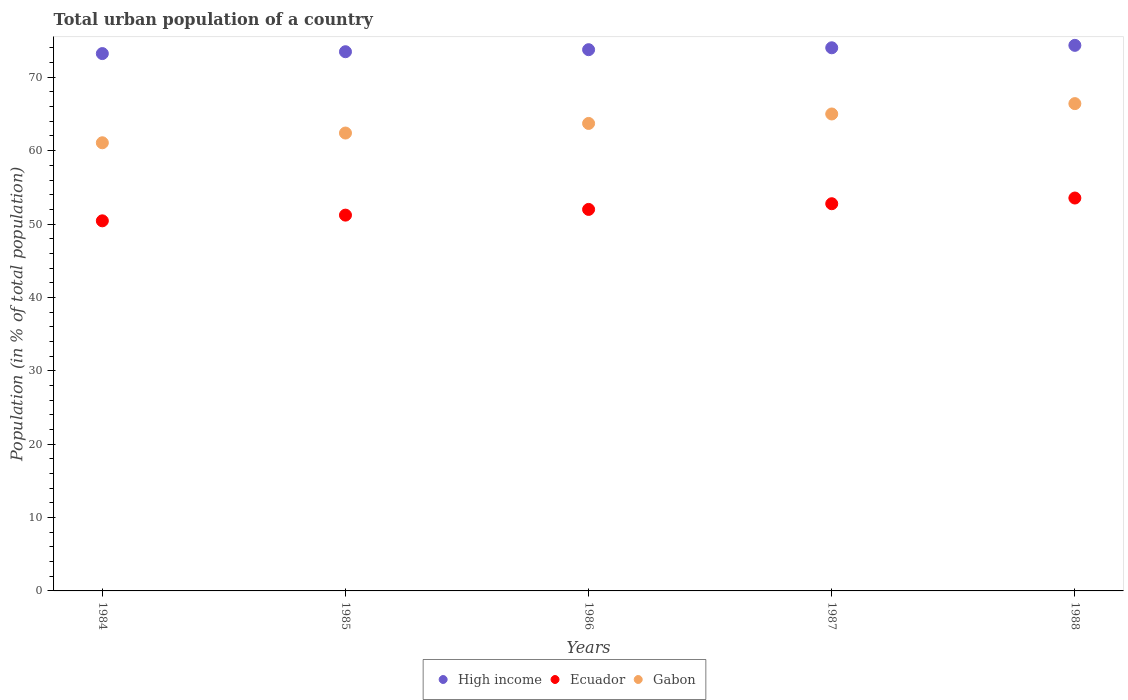What is the urban population in Gabon in 1986?
Your answer should be compact. 63.71. Across all years, what is the maximum urban population in Gabon?
Offer a terse response. 66.41. Across all years, what is the minimum urban population in Gabon?
Your response must be concise. 61.08. In which year was the urban population in Gabon minimum?
Provide a short and direct response. 1984. What is the total urban population in High income in the graph?
Provide a short and direct response. 368.85. What is the difference between the urban population in Gabon in 1984 and that in 1985?
Ensure brevity in your answer.  -1.33. What is the difference between the urban population in Ecuador in 1988 and the urban population in High income in 1986?
Ensure brevity in your answer.  -20.22. What is the average urban population in Gabon per year?
Offer a terse response. 63.72. In the year 1985, what is the difference between the urban population in High income and urban population in Ecuador?
Make the answer very short. 22.27. In how many years, is the urban population in Gabon greater than 42 %?
Your answer should be very brief. 5. What is the ratio of the urban population in Gabon in 1985 to that in 1988?
Ensure brevity in your answer.  0.94. Is the difference between the urban population in High income in 1986 and 1987 greater than the difference between the urban population in Ecuador in 1986 and 1987?
Give a very brief answer. Yes. What is the difference between the highest and the second highest urban population in Ecuador?
Your response must be concise. 0.78. What is the difference between the highest and the lowest urban population in Ecuador?
Keep it short and to the point. 3.11. Is the sum of the urban population in Gabon in 1985 and 1986 greater than the maximum urban population in Ecuador across all years?
Your response must be concise. Yes. Does the urban population in High income monotonically increase over the years?
Provide a succinct answer. Yes. Is the urban population in Gabon strictly greater than the urban population in High income over the years?
Offer a terse response. No. Is the urban population in Ecuador strictly less than the urban population in High income over the years?
Keep it short and to the point. Yes. How many dotlines are there?
Provide a short and direct response. 3. How many years are there in the graph?
Offer a terse response. 5. What is the difference between two consecutive major ticks on the Y-axis?
Your answer should be very brief. 10. Are the values on the major ticks of Y-axis written in scientific E-notation?
Offer a terse response. No. Does the graph contain any zero values?
Your answer should be compact. No. Where does the legend appear in the graph?
Provide a succinct answer. Bottom center. How are the legend labels stacked?
Make the answer very short. Horizontal. What is the title of the graph?
Your answer should be compact. Total urban population of a country. Does "Low & middle income" appear as one of the legend labels in the graph?
Keep it short and to the point. No. What is the label or title of the X-axis?
Give a very brief answer. Years. What is the label or title of the Y-axis?
Provide a short and direct response. Population (in % of total population). What is the Population (in % of total population) of High income in 1984?
Ensure brevity in your answer.  73.23. What is the Population (in % of total population) of Ecuador in 1984?
Give a very brief answer. 50.44. What is the Population (in % of total population) of Gabon in 1984?
Provide a succinct answer. 61.08. What is the Population (in % of total population) in High income in 1985?
Offer a very short reply. 73.48. What is the Population (in % of total population) of Ecuador in 1985?
Your response must be concise. 51.22. What is the Population (in % of total population) of Gabon in 1985?
Your answer should be compact. 62.4. What is the Population (in % of total population) in High income in 1986?
Make the answer very short. 73.76. What is the Population (in % of total population) in Ecuador in 1986?
Your answer should be very brief. 51.99. What is the Population (in % of total population) of Gabon in 1986?
Ensure brevity in your answer.  63.71. What is the Population (in % of total population) of High income in 1987?
Ensure brevity in your answer.  74.02. What is the Population (in % of total population) in Ecuador in 1987?
Offer a terse response. 52.77. What is the Population (in % of total population) of High income in 1988?
Your answer should be compact. 74.35. What is the Population (in % of total population) of Ecuador in 1988?
Your answer should be compact. 53.55. What is the Population (in % of total population) in Gabon in 1988?
Keep it short and to the point. 66.41. Across all years, what is the maximum Population (in % of total population) of High income?
Provide a succinct answer. 74.35. Across all years, what is the maximum Population (in % of total population) of Ecuador?
Make the answer very short. 53.55. Across all years, what is the maximum Population (in % of total population) in Gabon?
Ensure brevity in your answer.  66.41. Across all years, what is the minimum Population (in % of total population) of High income?
Provide a succinct answer. 73.23. Across all years, what is the minimum Population (in % of total population) in Ecuador?
Provide a short and direct response. 50.44. Across all years, what is the minimum Population (in % of total population) of Gabon?
Make the answer very short. 61.08. What is the total Population (in % of total population) of High income in the graph?
Make the answer very short. 368.85. What is the total Population (in % of total population) in Ecuador in the graph?
Your response must be concise. 259.96. What is the total Population (in % of total population) in Gabon in the graph?
Provide a succinct answer. 318.6. What is the difference between the Population (in % of total population) in High income in 1984 and that in 1985?
Provide a short and direct response. -0.25. What is the difference between the Population (in % of total population) of Ecuador in 1984 and that in 1985?
Keep it short and to the point. -0.78. What is the difference between the Population (in % of total population) in Gabon in 1984 and that in 1985?
Your response must be concise. -1.33. What is the difference between the Population (in % of total population) of High income in 1984 and that in 1986?
Your response must be concise. -0.53. What is the difference between the Population (in % of total population) in Ecuador in 1984 and that in 1986?
Make the answer very short. -1.55. What is the difference between the Population (in % of total population) of Gabon in 1984 and that in 1986?
Make the answer very short. -2.63. What is the difference between the Population (in % of total population) of High income in 1984 and that in 1987?
Offer a very short reply. -0.79. What is the difference between the Population (in % of total population) in Ecuador in 1984 and that in 1987?
Offer a very short reply. -2.33. What is the difference between the Population (in % of total population) in Gabon in 1984 and that in 1987?
Provide a short and direct response. -3.92. What is the difference between the Population (in % of total population) of High income in 1984 and that in 1988?
Make the answer very short. -1.12. What is the difference between the Population (in % of total population) in Ecuador in 1984 and that in 1988?
Keep it short and to the point. -3.11. What is the difference between the Population (in % of total population) of Gabon in 1984 and that in 1988?
Make the answer very short. -5.34. What is the difference between the Population (in % of total population) of High income in 1985 and that in 1986?
Your answer should be compact. -0.28. What is the difference between the Population (in % of total population) of Ecuador in 1985 and that in 1986?
Your response must be concise. -0.78. What is the difference between the Population (in % of total population) in Gabon in 1985 and that in 1986?
Ensure brevity in your answer.  -1.31. What is the difference between the Population (in % of total population) of High income in 1985 and that in 1987?
Offer a very short reply. -0.54. What is the difference between the Population (in % of total population) of Ecuador in 1985 and that in 1987?
Offer a very short reply. -1.55. What is the difference between the Population (in % of total population) of Gabon in 1985 and that in 1987?
Keep it short and to the point. -2.6. What is the difference between the Population (in % of total population) of High income in 1985 and that in 1988?
Your answer should be very brief. -0.87. What is the difference between the Population (in % of total population) of Ecuador in 1985 and that in 1988?
Provide a succinct answer. -2.33. What is the difference between the Population (in % of total population) in Gabon in 1985 and that in 1988?
Offer a terse response. -4.01. What is the difference between the Population (in % of total population) in High income in 1986 and that in 1987?
Make the answer very short. -0.26. What is the difference between the Population (in % of total population) in Ecuador in 1986 and that in 1987?
Give a very brief answer. -0.78. What is the difference between the Population (in % of total population) of Gabon in 1986 and that in 1987?
Offer a terse response. -1.29. What is the difference between the Population (in % of total population) of High income in 1986 and that in 1988?
Provide a short and direct response. -0.59. What is the difference between the Population (in % of total population) of Ecuador in 1986 and that in 1988?
Offer a terse response. -1.55. What is the difference between the Population (in % of total population) in Gabon in 1986 and that in 1988?
Offer a terse response. -2.7. What is the difference between the Population (in % of total population) in High income in 1987 and that in 1988?
Offer a very short reply. -0.33. What is the difference between the Population (in % of total population) in Ecuador in 1987 and that in 1988?
Ensure brevity in your answer.  -0.78. What is the difference between the Population (in % of total population) in Gabon in 1987 and that in 1988?
Your answer should be very brief. -1.41. What is the difference between the Population (in % of total population) in High income in 1984 and the Population (in % of total population) in Ecuador in 1985?
Your answer should be very brief. 22.02. What is the difference between the Population (in % of total population) of High income in 1984 and the Population (in % of total population) of Gabon in 1985?
Give a very brief answer. 10.83. What is the difference between the Population (in % of total population) of Ecuador in 1984 and the Population (in % of total population) of Gabon in 1985?
Offer a terse response. -11.96. What is the difference between the Population (in % of total population) in High income in 1984 and the Population (in % of total population) in Ecuador in 1986?
Provide a short and direct response. 21.24. What is the difference between the Population (in % of total population) in High income in 1984 and the Population (in % of total population) in Gabon in 1986?
Provide a short and direct response. 9.52. What is the difference between the Population (in % of total population) of Ecuador in 1984 and the Population (in % of total population) of Gabon in 1986?
Keep it short and to the point. -13.27. What is the difference between the Population (in % of total population) in High income in 1984 and the Population (in % of total population) in Ecuador in 1987?
Provide a succinct answer. 20.46. What is the difference between the Population (in % of total population) in High income in 1984 and the Population (in % of total population) in Gabon in 1987?
Provide a succinct answer. 8.23. What is the difference between the Population (in % of total population) of Ecuador in 1984 and the Population (in % of total population) of Gabon in 1987?
Provide a short and direct response. -14.56. What is the difference between the Population (in % of total population) of High income in 1984 and the Population (in % of total population) of Ecuador in 1988?
Make the answer very short. 19.69. What is the difference between the Population (in % of total population) in High income in 1984 and the Population (in % of total population) in Gabon in 1988?
Provide a succinct answer. 6.82. What is the difference between the Population (in % of total population) in Ecuador in 1984 and the Population (in % of total population) in Gabon in 1988?
Keep it short and to the point. -15.97. What is the difference between the Population (in % of total population) of High income in 1985 and the Population (in % of total population) of Ecuador in 1986?
Your answer should be very brief. 21.49. What is the difference between the Population (in % of total population) in High income in 1985 and the Population (in % of total population) in Gabon in 1986?
Provide a succinct answer. 9.77. What is the difference between the Population (in % of total population) in Ecuador in 1985 and the Population (in % of total population) in Gabon in 1986?
Your answer should be compact. -12.5. What is the difference between the Population (in % of total population) of High income in 1985 and the Population (in % of total population) of Ecuador in 1987?
Your answer should be compact. 20.72. What is the difference between the Population (in % of total population) of High income in 1985 and the Population (in % of total population) of Gabon in 1987?
Keep it short and to the point. 8.48. What is the difference between the Population (in % of total population) of Ecuador in 1985 and the Population (in % of total population) of Gabon in 1987?
Offer a terse response. -13.79. What is the difference between the Population (in % of total population) in High income in 1985 and the Population (in % of total population) in Ecuador in 1988?
Your response must be concise. 19.94. What is the difference between the Population (in % of total population) of High income in 1985 and the Population (in % of total population) of Gabon in 1988?
Provide a short and direct response. 7.07. What is the difference between the Population (in % of total population) in Ecuador in 1985 and the Population (in % of total population) in Gabon in 1988?
Offer a very short reply. -15.2. What is the difference between the Population (in % of total population) of High income in 1986 and the Population (in % of total population) of Ecuador in 1987?
Make the answer very short. 20.99. What is the difference between the Population (in % of total population) of High income in 1986 and the Population (in % of total population) of Gabon in 1987?
Ensure brevity in your answer.  8.76. What is the difference between the Population (in % of total population) in Ecuador in 1986 and the Population (in % of total population) in Gabon in 1987?
Your answer should be very brief. -13.01. What is the difference between the Population (in % of total population) in High income in 1986 and the Population (in % of total population) in Ecuador in 1988?
Give a very brief answer. 20.22. What is the difference between the Population (in % of total population) of High income in 1986 and the Population (in % of total population) of Gabon in 1988?
Your answer should be very brief. 7.35. What is the difference between the Population (in % of total population) in Ecuador in 1986 and the Population (in % of total population) in Gabon in 1988?
Your answer should be very brief. -14.42. What is the difference between the Population (in % of total population) of High income in 1987 and the Population (in % of total population) of Ecuador in 1988?
Provide a short and direct response. 20.47. What is the difference between the Population (in % of total population) of High income in 1987 and the Population (in % of total population) of Gabon in 1988?
Ensure brevity in your answer.  7.61. What is the difference between the Population (in % of total population) in Ecuador in 1987 and the Population (in % of total population) in Gabon in 1988?
Provide a short and direct response. -13.64. What is the average Population (in % of total population) of High income per year?
Your answer should be compact. 73.77. What is the average Population (in % of total population) of Ecuador per year?
Make the answer very short. 51.99. What is the average Population (in % of total population) of Gabon per year?
Your answer should be very brief. 63.72. In the year 1984, what is the difference between the Population (in % of total population) in High income and Population (in % of total population) in Ecuador?
Offer a terse response. 22.79. In the year 1984, what is the difference between the Population (in % of total population) in High income and Population (in % of total population) in Gabon?
Keep it short and to the point. 12.16. In the year 1984, what is the difference between the Population (in % of total population) of Ecuador and Population (in % of total population) of Gabon?
Offer a very short reply. -10.64. In the year 1985, what is the difference between the Population (in % of total population) in High income and Population (in % of total population) in Ecuador?
Offer a terse response. 22.27. In the year 1985, what is the difference between the Population (in % of total population) of High income and Population (in % of total population) of Gabon?
Your answer should be compact. 11.08. In the year 1985, what is the difference between the Population (in % of total population) in Ecuador and Population (in % of total population) in Gabon?
Offer a very short reply. -11.19. In the year 1986, what is the difference between the Population (in % of total population) in High income and Population (in % of total population) in Ecuador?
Give a very brief answer. 21.77. In the year 1986, what is the difference between the Population (in % of total population) of High income and Population (in % of total population) of Gabon?
Your answer should be very brief. 10.05. In the year 1986, what is the difference between the Population (in % of total population) of Ecuador and Population (in % of total population) of Gabon?
Provide a succinct answer. -11.72. In the year 1987, what is the difference between the Population (in % of total population) in High income and Population (in % of total population) in Ecuador?
Offer a very short reply. 21.25. In the year 1987, what is the difference between the Population (in % of total population) of High income and Population (in % of total population) of Gabon?
Offer a terse response. 9.02. In the year 1987, what is the difference between the Population (in % of total population) of Ecuador and Population (in % of total population) of Gabon?
Your answer should be compact. -12.23. In the year 1988, what is the difference between the Population (in % of total population) in High income and Population (in % of total population) in Ecuador?
Ensure brevity in your answer.  20.81. In the year 1988, what is the difference between the Population (in % of total population) in High income and Population (in % of total population) in Gabon?
Provide a short and direct response. 7.94. In the year 1988, what is the difference between the Population (in % of total population) in Ecuador and Population (in % of total population) in Gabon?
Keep it short and to the point. -12.87. What is the ratio of the Population (in % of total population) of Gabon in 1984 to that in 1985?
Offer a terse response. 0.98. What is the ratio of the Population (in % of total population) in High income in 1984 to that in 1986?
Provide a short and direct response. 0.99. What is the ratio of the Population (in % of total population) of Ecuador in 1984 to that in 1986?
Keep it short and to the point. 0.97. What is the ratio of the Population (in % of total population) of Gabon in 1984 to that in 1986?
Provide a succinct answer. 0.96. What is the ratio of the Population (in % of total population) in High income in 1984 to that in 1987?
Your answer should be compact. 0.99. What is the ratio of the Population (in % of total population) of Ecuador in 1984 to that in 1987?
Offer a terse response. 0.96. What is the ratio of the Population (in % of total population) in Gabon in 1984 to that in 1987?
Offer a very short reply. 0.94. What is the ratio of the Population (in % of total population) of High income in 1984 to that in 1988?
Offer a terse response. 0.98. What is the ratio of the Population (in % of total population) in Ecuador in 1984 to that in 1988?
Provide a succinct answer. 0.94. What is the ratio of the Population (in % of total population) in Gabon in 1984 to that in 1988?
Give a very brief answer. 0.92. What is the ratio of the Population (in % of total population) in High income in 1985 to that in 1986?
Provide a succinct answer. 1. What is the ratio of the Population (in % of total population) in Gabon in 1985 to that in 1986?
Give a very brief answer. 0.98. What is the ratio of the Population (in % of total population) of Ecuador in 1985 to that in 1987?
Your response must be concise. 0.97. What is the ratio of the Population (in % of total population) of High income in 1985 to that in 1988?
Keep it short and to the point. 0.99. What is the ratio of the Population (in % of total population) of Ecuador in 1985 to that in 1988?
Make the answer very short. 0.96. What is the ratio of the Population (in % of total population) in Gabon in 1985 to that in 1988?
Ensure brevity in your answer.  0.94. What is the ratio of the Population (in % of total population) in Gabon in 1986 to that in 1987?
Ensure brevity in your answer.  0.98. What is the ratio of the Population (in % of total population) in Gabon in 1986 to that in 1988?
Your response must be concise. 0.96. What is the ratio of the Population (in % of total population) of Ecuador in 1987 to that in 1988?
Your response must be concise. 0.99. What is the ratio of the Population (in % of total population) of Gabon in 1987 to that in 1988?
Ensure brevity in your answer.  0.98. What is the difference between the highest and the second highest Population (in % of total population) of High income?
Ensure brevity in your answer.  0.33. What is the difference between the highest and the second highest Population (in % of total population) in Ecuador?
Make the answer very short. 0.78. What is the difference between the highest and the second highest Population (in % of total population) in Gabon?
Give a very brief answer. 1.41. What is the difference between the highest and the lowest Population (in % of total population) of High income?
Offer a very short reply. 1.12. What is the difference between the highest and the lowest Population (in % of total population) of Ecuador?
Provide a succinct answer. 3.11. What is the difference between the highest and the lowest Population (in % of total population) of Gabon?
Give a very brief answer. 5.34. 